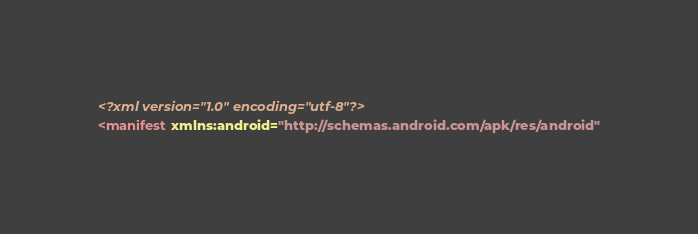<code> <loc_0><loc_0><loc_500><loc_500><_XML_><?xml version="1.0" encoding="utf-8"?>
<manifest xmlns:android="http://schemas.android.com/apk/res/android"</code> 